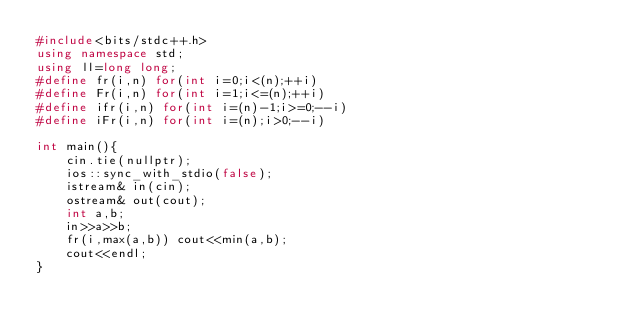Convert code to text. <code><loc_0><loc_0><loc_500><loc_500><_C++_>#include<bits/stdc++.h>
using namespace std;
using ll=long long;
#define fr(i,n) for(int i=0;i<(n);++i)
#define Fr(i,n) for(int i=1;i<=(n);++i)
#define ifr(i,n) for(int i=(n)-1;i>=0;--i)
#define iFr(i,n) for(int i=(n);i>0;--i)

int main(){
    cin.tie(nullptr);
    ios::sync_with_stdio(false);
    istream& in(cin);
    ostream& out(cout);
    int a,b;
    in>>a>>b;
    fr(i,max(a,b)) cout<<min(a,b);
    cout<<endl;
}</code> 